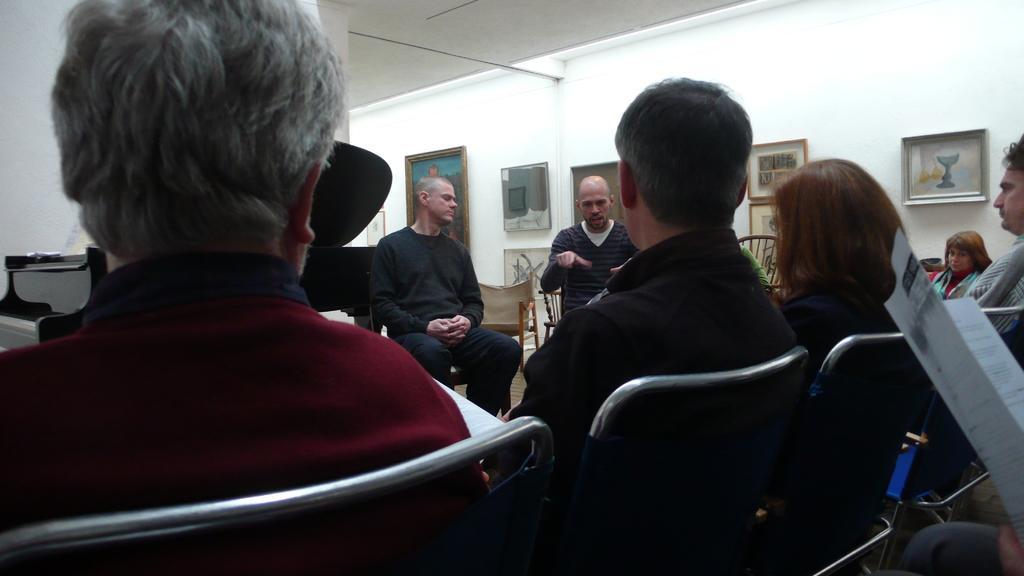Please provide a concise description of this image. There are many people sitting on chairs. On the right side a person is holding a book. In the back there is a wall with photo frames. 